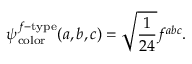Convert formula to latex. <formula><loc_0><loc_0><loc_500><loc_500>\psi _ { c o l o r } ^ { f - t y p e } ( a , b , c ) = \sqrt { \frac { 1 } { 2 4 } } f ^ { a b c } .</formula> 